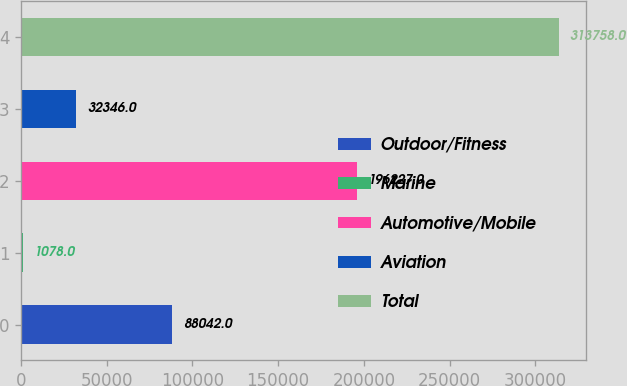<chart> <loc_0><loc_0><loc_500><loc_500><bar_chart><fcel>Outdoor/Fitness<fcel>Marine<fcel>Automotive/Mobile<fcel>Aviation<fcel>Total<nl><fcel>88042<fcel>1078<fcel>196227<fcel>32346<fcel>313758<nl></chart> 